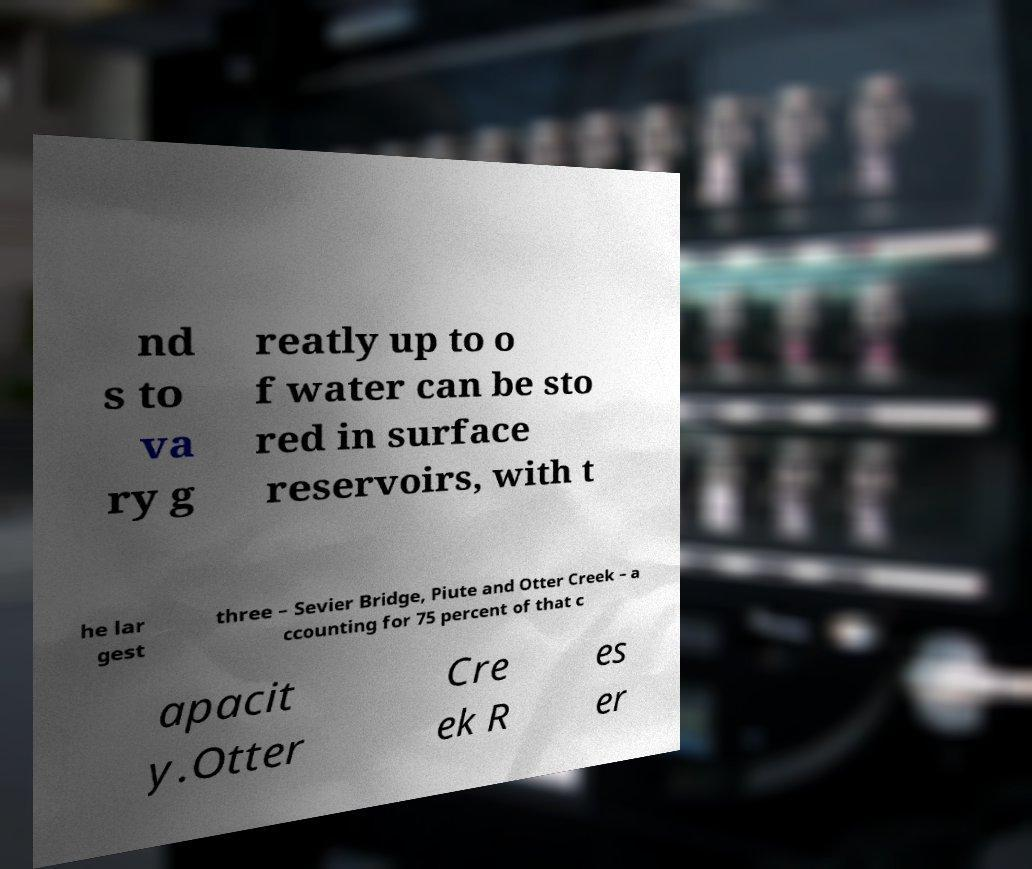Can you accurately transcribe the text from the provided image for me? nd s to va ry g reatly up to o f water can be sto red in surface reservoirs, with t he lar gest three – Sevier Bridge, Piute and Otter Creek – a ccounting for 75 percent of that c apacit y.Otter Cre ek R es er 